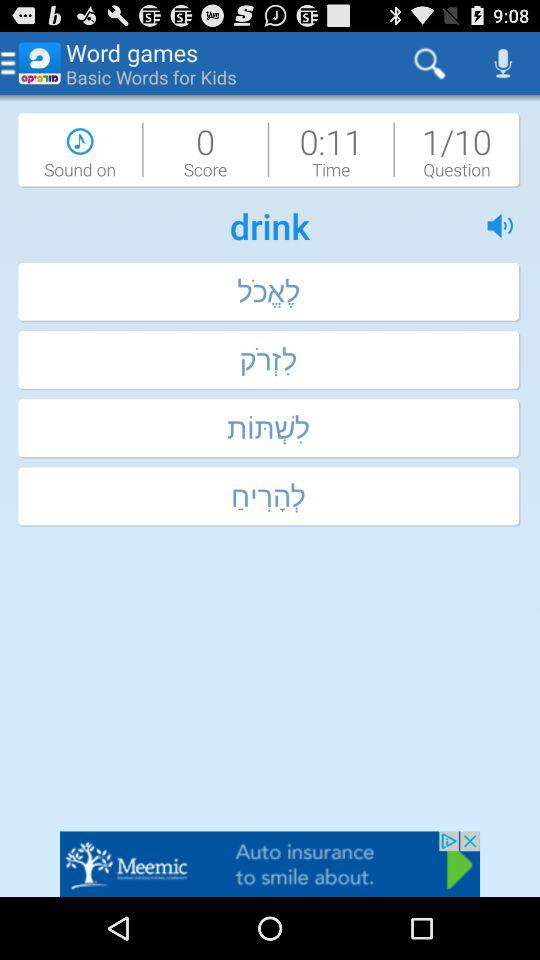Is "Sound" on or off?
Answer the question using a single word or phrase. "Sound" is on. 